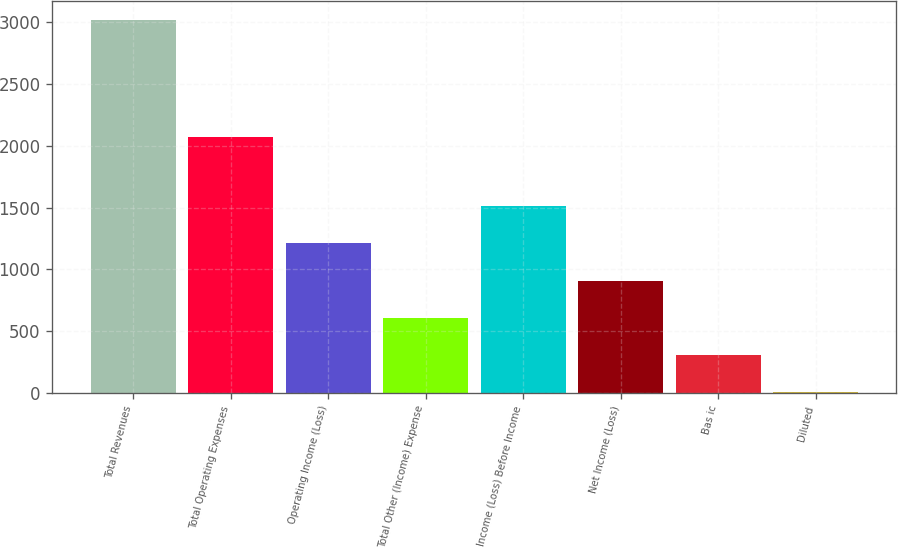<chart> <loc_0><loc_0><loc_500><loc_500><bar_chart><fcel>Total Revenues<fcel>Total Operating Expenses<fcel>Operating Income (Loss)<fcel>Total Other (Income) Expense<fcel>Income (Loss) Before Income<fcel>Net Income (Loss)<fcel>Bas ic<fcel>Diluted<nl><fcel>3022<fcel>2070<fcel>1211.26<fcel>607.68<fcel>1513.05<fcel>909.47<fcel>305.89<fcel>4.1<nl></chart> 